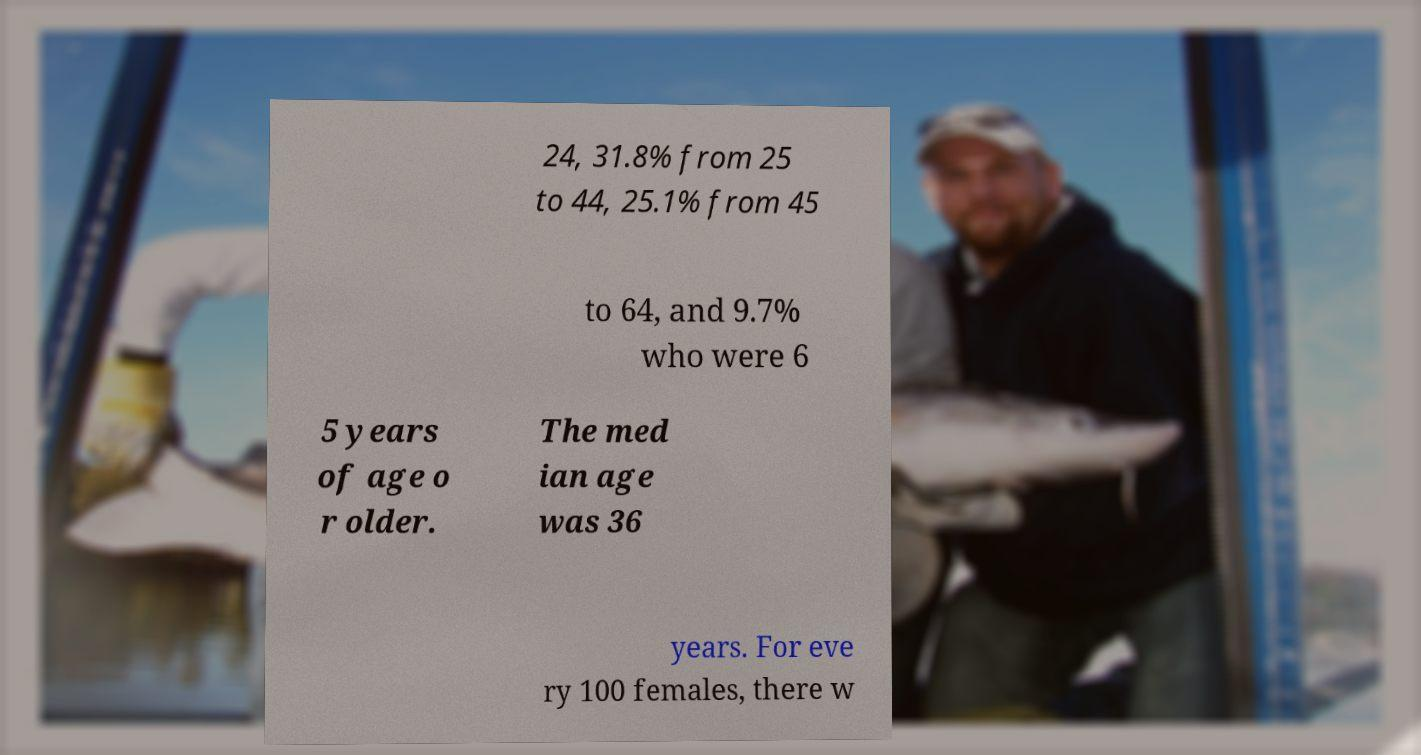Can you read and provide the text displayed in the image?This photo seems to have some interesting text. Can you extract and type it out for me? 24, 31.8% from 25 to 44, 25.1% from 45 to 64, and 9.7% who were 6 5 years of age o r older. The med ian age was 36 years. For eve ry 100 females, there w 